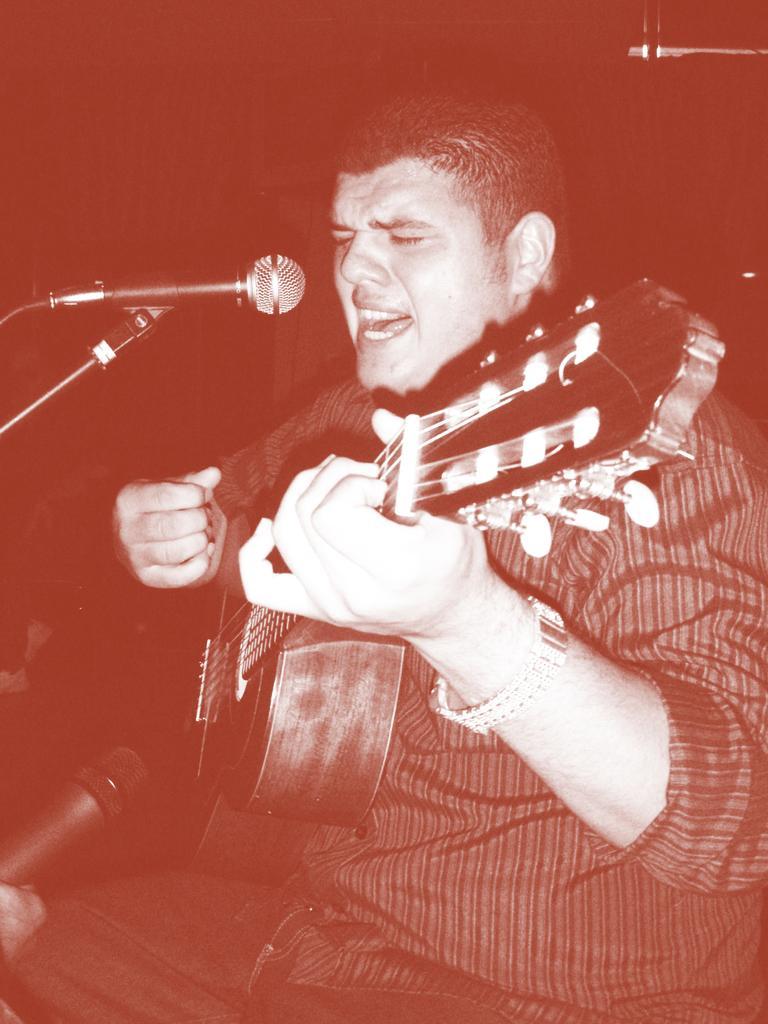Can you describe this image briefly? In this image we can see a man sitting and playing a guitar. There are mics. 